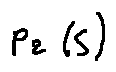<formula> <loc_0><loc_0><loc_500><loc_500>p _ { 2 } ( s )</formula> 